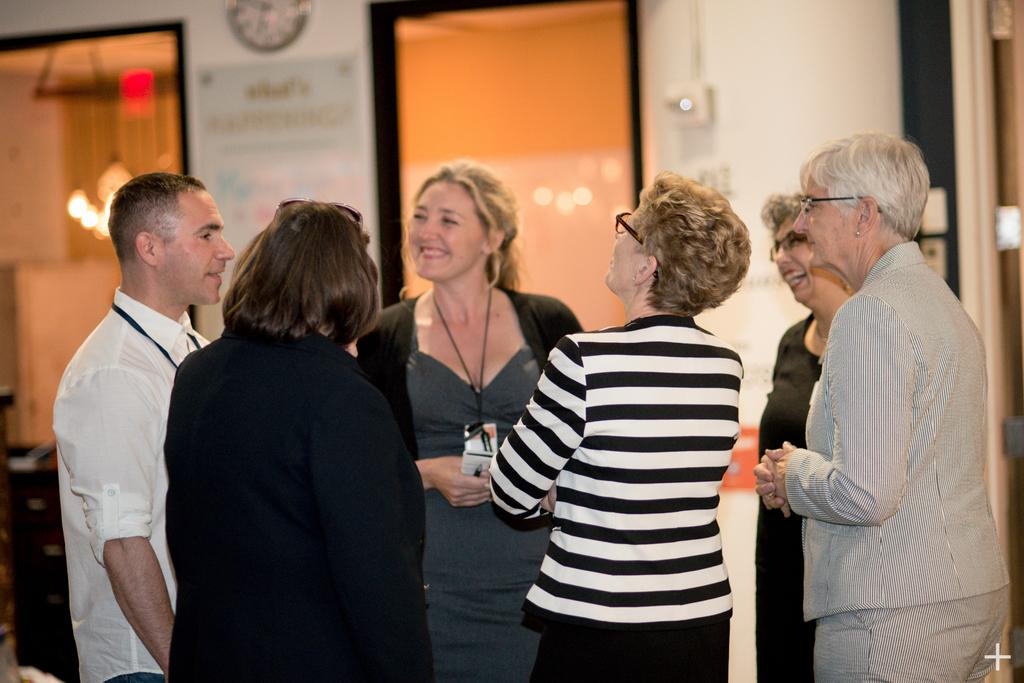What can be seen in the image involving people? There are people standing in the image. What time-related object is visible in the image? There is a wall clock visible in the image. What type of surface has written text in the image? There is written text on a board in the image. What type of transparent material is present in the image? There are glass windows in the image. What type of illumination is present in the image? There are lights in the image. How many rings are being worn by the people in the image? There is no information about rings being worn by the people in the image. What thing is being burned in the image? There is no object being burned in the image. 